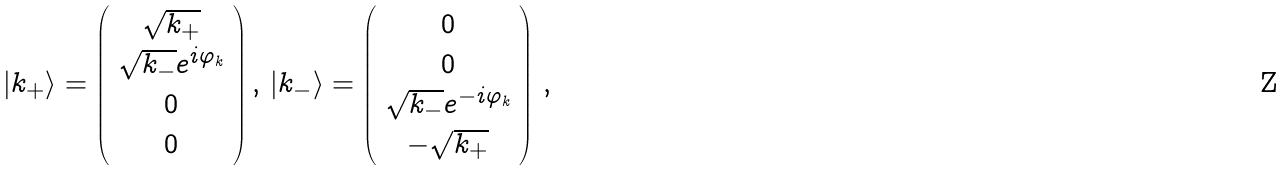Convert formula to latex. <formula><loc_0><loc_0><loc_500><loc_500>| k _ { + } \rangle = \left ( \begin{array} { c } \sqrt { k _ { + } } \\ \sqrt { k _ { - } } e ^ { i \varphi _ { k } } \\ 0 \\ 0 \end{array} \right ) , \, | k _ { - } \rangle = \left ( \begin{array} { c } 0 \\ 0 \\ \sqrt { k _ { - } } e ^ { - i \varphi _ { k } } \\ - \sqrt { k _ { + } } \end{array} \right ) \, ,</formula> 